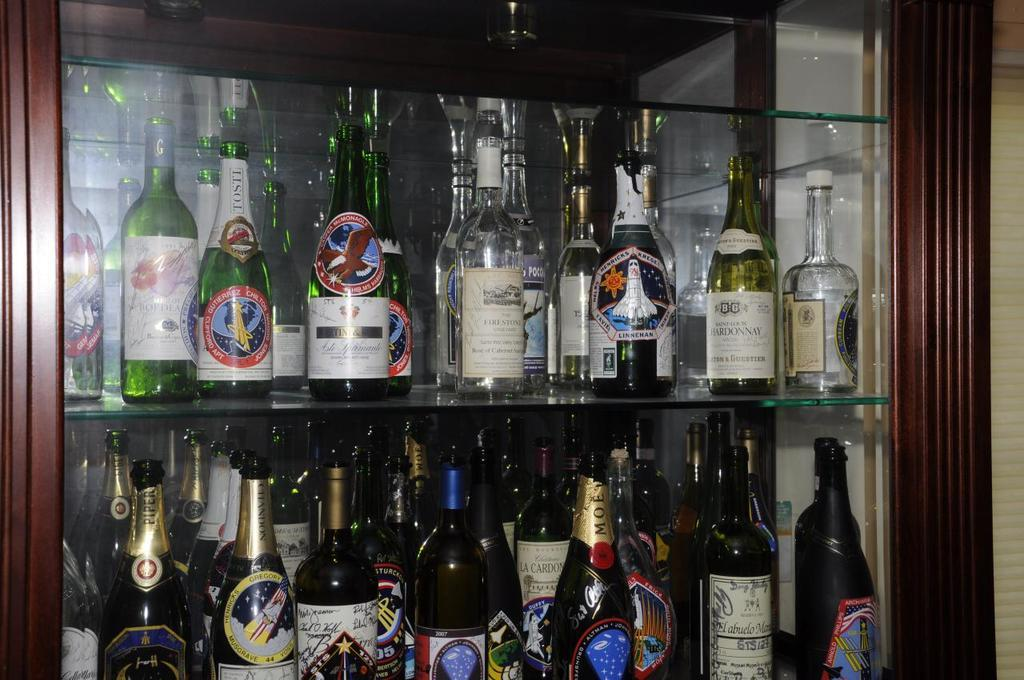What objects are visible in the image? There are bottles in the image. How are the bottles arranged? The bottles are placed on a rack. What can be seen in the background of the image? There is a wall in the image. What type of cheese is being served in the office setting in the image? There is no cheese or office setting present in the image; it only features bottles on a rack and a wall in the background. 